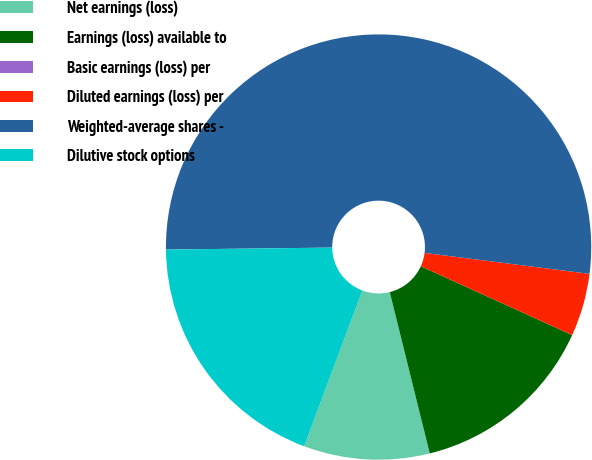Convert chart to OTSL. <chart><loc_0><loc_0><loc_500><loc_500><pie_chart><fcel>Net earnings (loss)<fcel>Earnings (loss) available to<fcel>Basic earnings (loss) per<fcel>Diluted earnings (loss) per<fcel>Weighted-average shares -<fcel>Dilutive stock options<nl><fcel>9.56%<fcel>14.34%<fcel>0.0%<fcel>4.78%<fcel>52.2%<fcel>19.12%<nl></chart> 